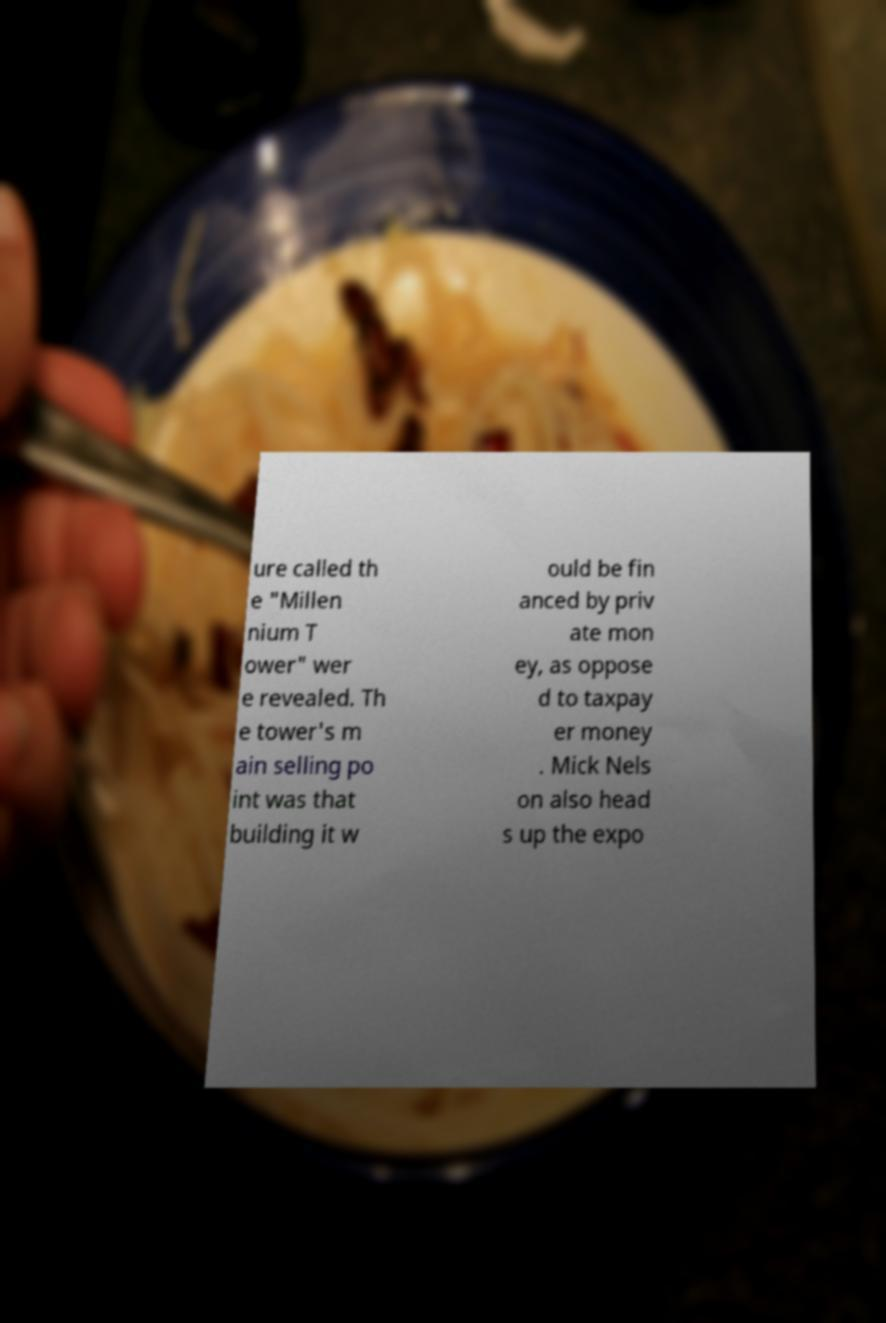Please identify and transcribe the text found in this image. ure called th e "Millen nium T ower" wer e revealed. Th e tower's m ain selling po int was that building it w ould be fin anced by priv ate mon ey, as oppose d to taxpay er money . Mick Nels on also head s up the expo 